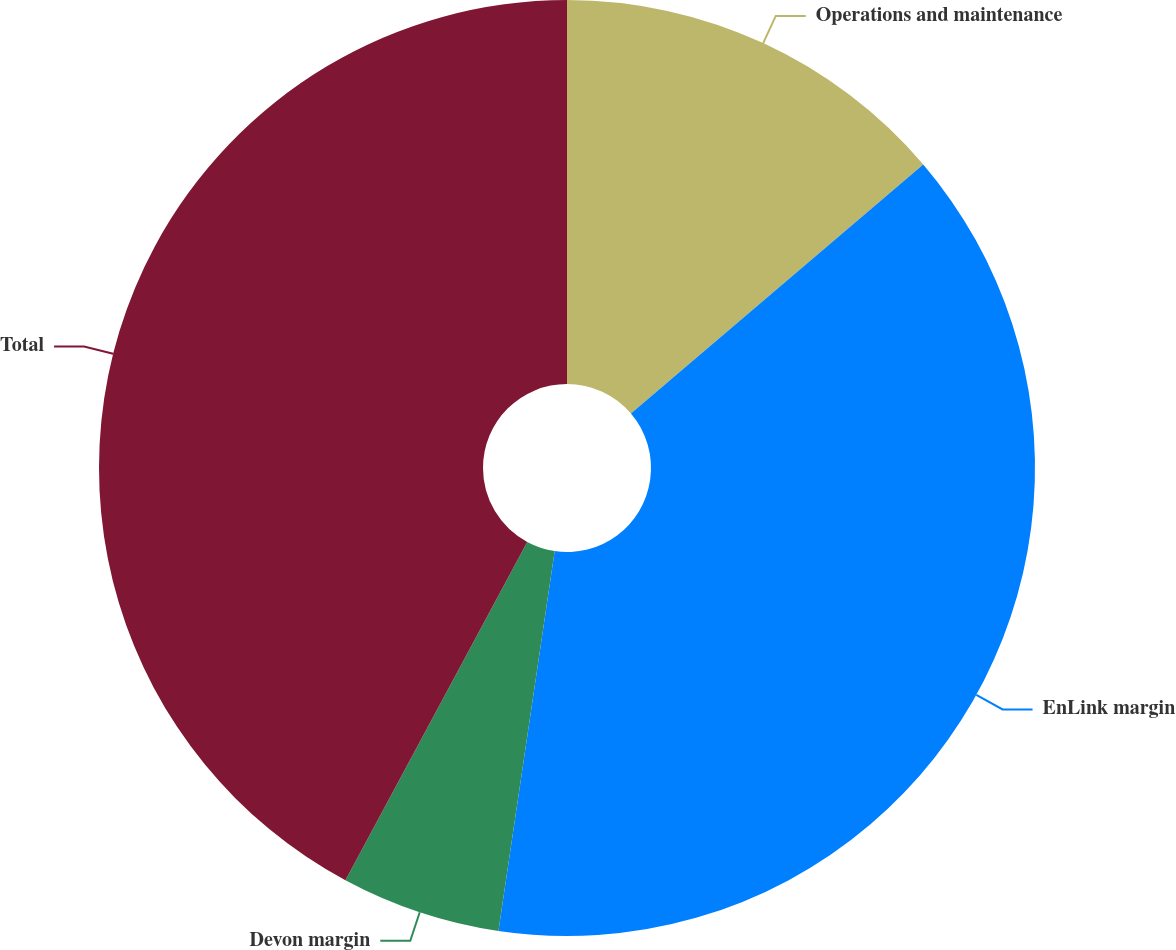Convert chart to OTSL. <chart><loc_0><loc_0><loc_500><loc_500><pie_chart><fcel>Operations and maintenance<fcel>EnLink margin<fcel>Devon margin<fcel>Total<nl><fcel>13.77%<fcel>38.57%<fcel>5.51%<fcel>42.15%<nl></chart> 